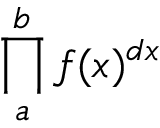Convert formula to latex. <formula><loc_0><loc_0><loc_500><loc_500>\prod _ { a } ^ { b } f ( x ) ^ { d x }</formula> 